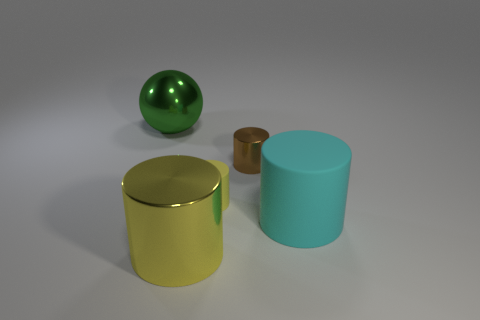Add 2 tiny green shiny things. How many objects exist? 7 Subtract all brown metal cylinders. How many cylinders are left? 3 Subtract all yellow cylinders. How many cylinders are left? 2 Subtract all brown cubes. How many yellow cylinders are left? 2 Subtract all spheres. How many objects are left? 4 Add 2 tiny brown shiny cylinders. How many tiny brown shiny cylinders are left? 3 Add 2 big rubber objects. How many big rubber objects exist? 3 Subtract 0 purple cylinders. How many objects are left? 5 Subtract 1 spheres. How many spheres are left? 0 Subtract all blue spheres. Subtract all brown cylinders. How many spheres are left? 1 